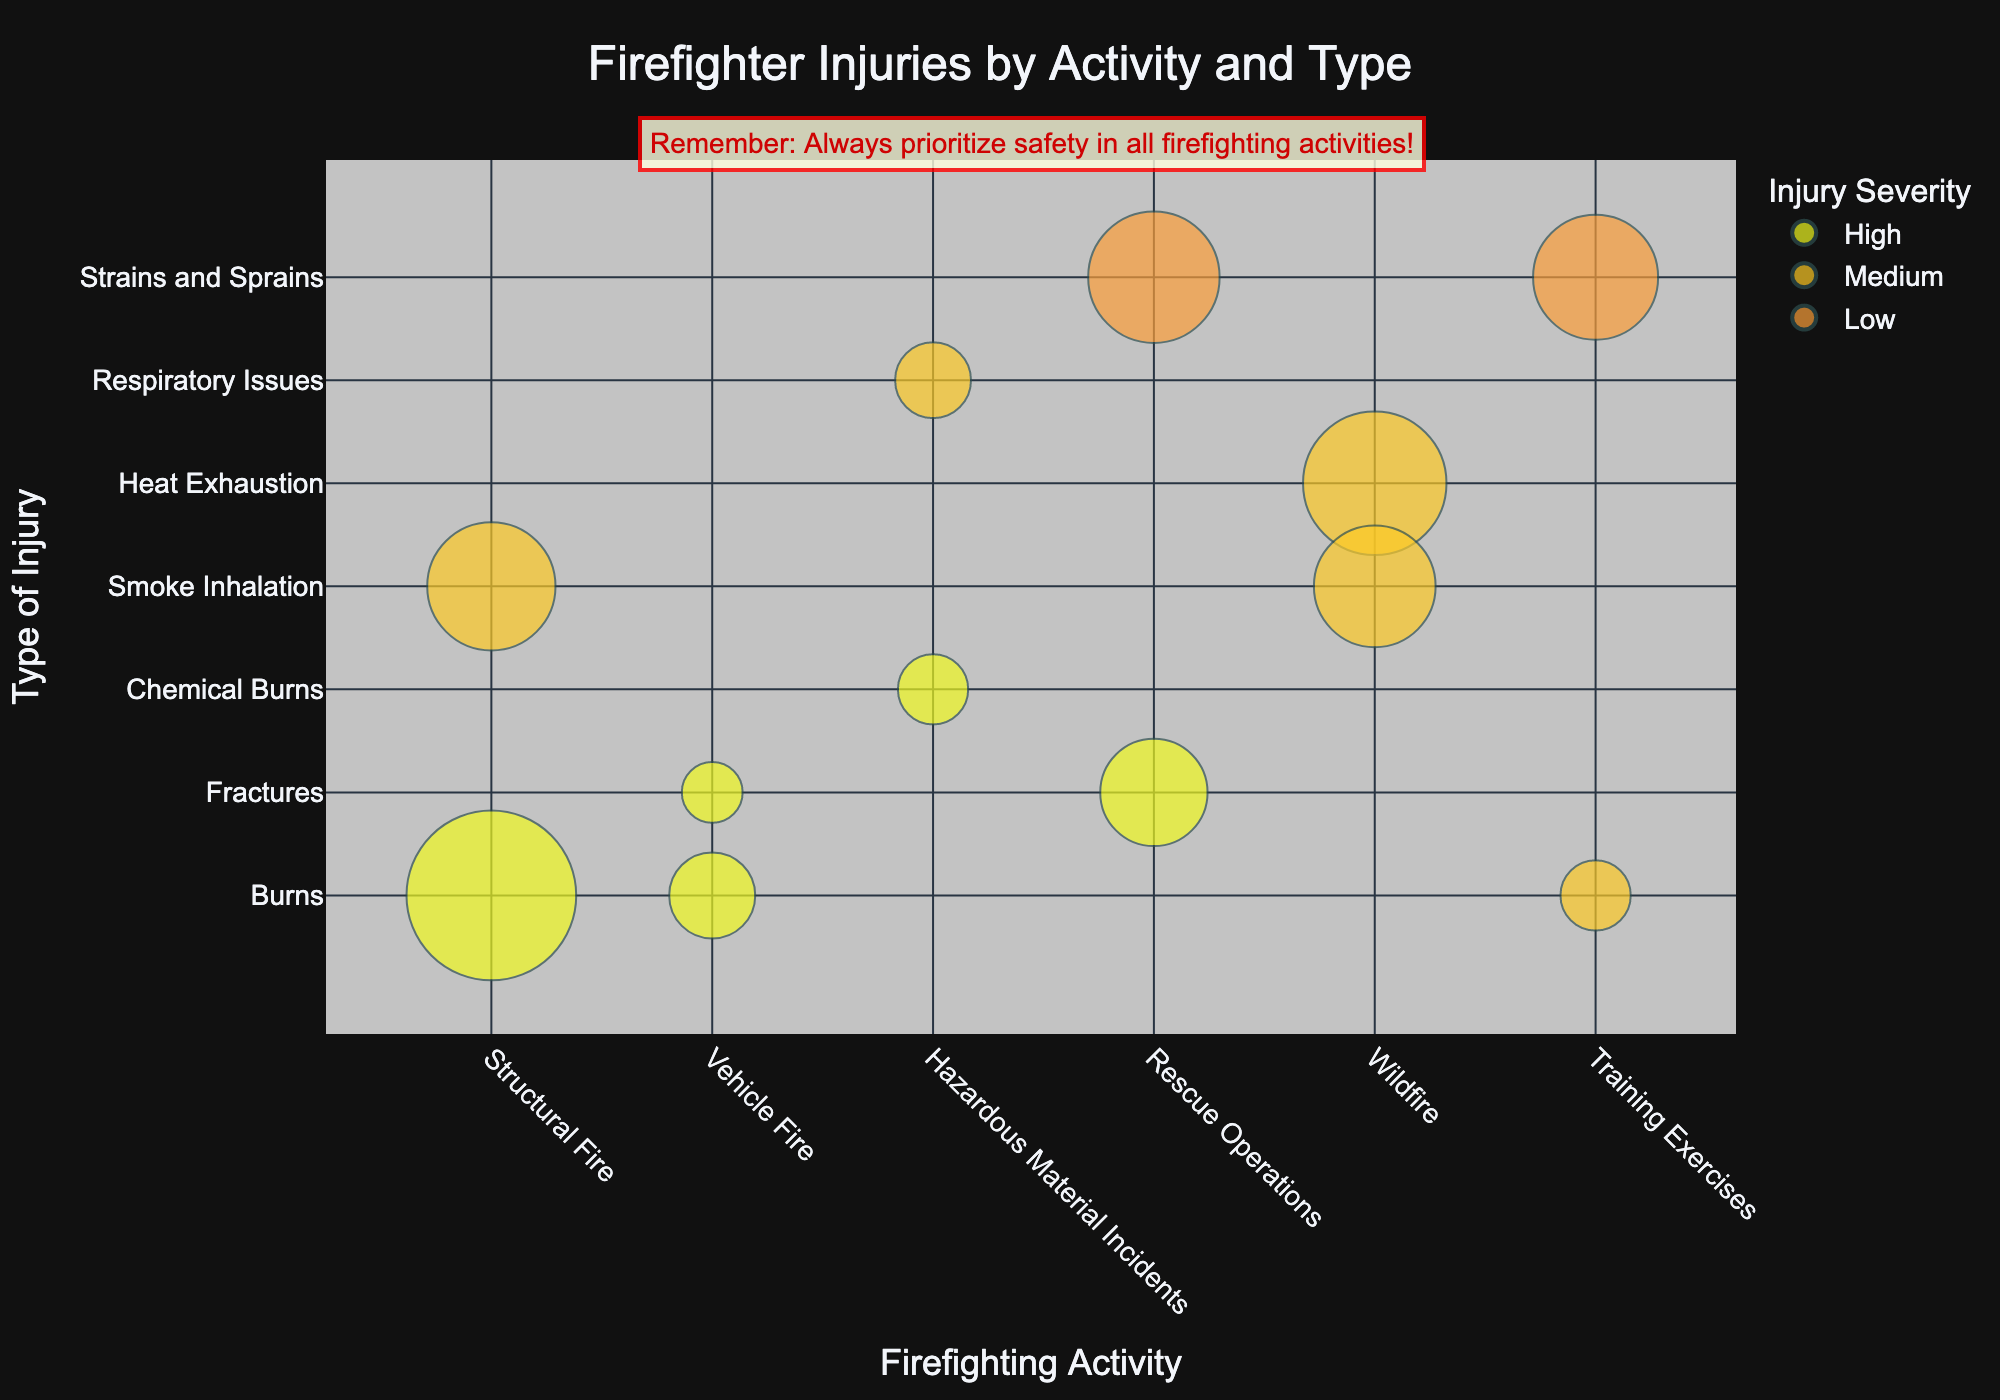How many types of injuries are listed in the chart? By looking at the y-axis, we can count the distinct injury types appearing on the plot, which include Burns, Smoke Inhalation, Heat Exhaustion, Fractures, Chemical Burns, Respiratory Issues, and Strains and Sprains.
Answer: 7 What activity has the highest number of injuries for burns? To find this, look at the size of the bubble for 'Burns' under each activity. The largest bubble corresponds to 'Structural Fire' with 350 injuries.
Answer: Structural Fire Which injury type under Rescue Operations has the higher number of injuries? Compare the sizes of the bubbles for 'Rescue Operations' regarding 'Fractures' and 'Strains and Sprains'. The bubble for 'Strains and Sprains' is larger, representing 210 injuries compared to 140 for 'Fractures'.
Answer: Strains and Sprains What is the severity level for most injuries in Training Exercises? By looking at the bubbles under 'Training Exercises', we can see the colors indicating severity. 'Strains and Sprains' with low severity and 'Burns' with medium severity are present. The larger bubble for 'Strains and Sprains' and low severity is most prevalent.
Answer: Low How does the number of injuries due to smoke inhalation in Wildfire compare to that in Structural Fire? Compare the sizes of the corresponding bubbles: 'Wildfire' Smoke Inhalation (180) vs. 'Structural Fire' Smoke Inhalation (200). 'Structural Fire' has more injuries due to smoke inhalation.
Answer: Structural Fire has more What is the average number of injuries per type for Hazardous Material Incidents? Add the number of injuries for 'Chemical Burns' (60) and 'Respiratory Issues' (70), which equals 130. Divide this by 2, since there are 2 types of injuries. The result is (60 + 70)/2 = 65.
Answer: 65 Which activity has bubbles with the highest frequency? By examining the x-axis, observe which activity appears with more different types of injuries. 'Structural Fire' and 'Wildfire' both have multiple injury types, but 'Structural Fire' has slightly more with burns and smoke inhalation.
Answer: Structural Fire Are burns more severe in Structural Fire or Training Exercises? Check the color indicating severity for 'Burns' under both activities. 'Burns' in 'Structural Fire' are marked as high severity, while in 'Training Exercises', they are medium severity.
Answer: Structural Fire Which activity has the fewest reported injury types? Identify the activity with the smallest number of distinct injury type labels on the y-axis. 'Vehicle Fire' has only two injury types listed (Burns and Fractures).
Answer: Vehicle Fire 